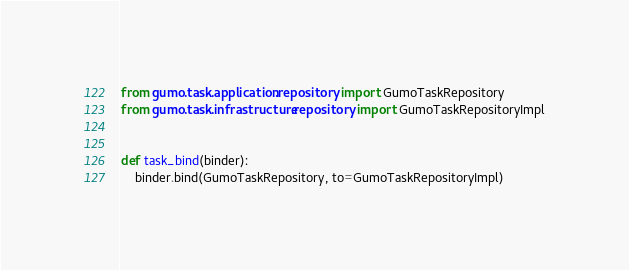Convert code to text. <code><loc_0><loc_0><loc_500><loc_500><_Python_>from gumo.task.application.repository import GumoTaskRepository
from gumo.task.infrastructure.repository import GumoTaskRepositoryImpl


def task_bind(binder):
    binder.bind(GumoTaskRepository, to=GumoTaskRepositoryImpl)
</code> 